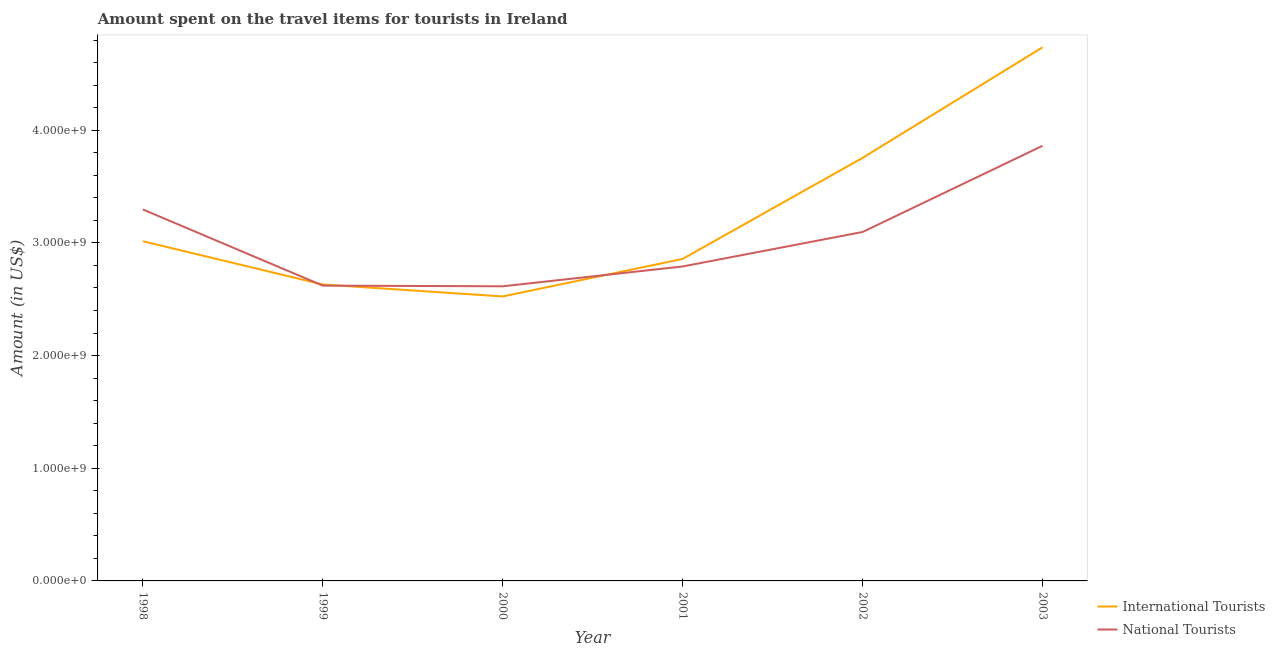How many different coloured lines are there?
Make the answer very short. 2. Is the number of lines equal to the number of legend labels?
Provide a succinct answer. Yes. What is the amount spent on travel items of international tourists in 2000?
Ensure brevity in your answer.  2.52e+09. Across all years, what is the maximum amount spent on travel items of national tourists?
Give a very brief answer. 3.86e+09. Across all years, what is the minimum amount spent on travel items of national tourists?
Provide a short and direct response. 2.62e+09. In which year was the amount spent on travel items of national tourists maximum?
Offer a very short reply. 2003. In which year was the amount spent on travel items of international tourists minimum?
Offer a very short reply. 2000. What is the total amount spent on travel items of international tourists in the graph?
Ensure brevity in your answer.  1.95e+1. What is the difference between the amount spent on travel items of international tourists in 2001 and that in 2002?
Provide a short and direct response. -8.97e+08. What is the difference between the amount spent on travel items of international tourists in 2002 and the amount spent on travel items of national tourists in 2000?
Ensure brevity in your answer.  1.14e+09. What is the average amount spent on travel items of international tourists per year?
Your response must be concise. 3.25e+09. In the year 2002, what is the difference between the amount spent on travel items of international tourists and amount spent on travel items of national tourists?
Offer a very short reply. 6.58e+08. What is the ratio of the amount spent on travel items of national tourists in 1999 to that in 2001?
Provide a succinct answer. 0.94. Is the difference between the amount spent on travel items of national tourists in 1999 and 2002 greater than the difference between the amount spent on travel items of international tourists in 1999 and 2002?
Provide a short and direct response. Yes. What is the difference between the highest and the second highest amount spent on travel items of national tourists?
Your response must be concise. 5.65e+08. What is the difference between the highest and the lowest amount spent on travel items of national tourists?
Provide a succinct answer. 1.25e+09. How many lines are there?
Offer a very short reply. 2. Does the graph contain any zero values?
Give a very brief answer. No. How many legend labels are there?
Offer a terse response. 2. How are the legend labels stacked?
Provide a succinct answer. Vertical. What is the title of the graph?
Offer a terse response. Amount spent on the travel items for tourists in Ireland. What is the label or title of the X-axis?
Provide a succinct answer. Year. What is the label or title of the Y-axis?
Your answer should be very brief. Amount (in US$). What is the Amount (in US$) in International Tourists in 1998?
Keep it short and to the point. 3.02e+09. What is the Amount (in US$) of National Tourists in 1998?
Offer a very short reply. 3.30e+09. What is the Amount (in US$) in International Tourists in 1999?
Your response must be concise. 2.63e+09. What is the Amount (in US$) in National Tourists in 1999?
Your answer should be very brief. 2.62e+09. What is the Amount (in US$) of International Tourists in 2000?
Give a very brief answer. 2.52e+09. What is the Amount (in US$) of National Tourists in 2000?
Offer a terse response. 2.62e+09. What is the Amount (in US$) of International Tourists in 2001?
Your response must be concise. 2.86e+09. What is the Amount (in US$) of National Tourists in 2001?
Your answer should be compact. 2.79e+09. What is the Amount (in US$) of International Tourists in 2002?
Provide a short and direct response. 3.76e+09. What is the Amount (in US$) of National Tourists in 2002?
Keep it short and to the point. 3.10e+09. What is the Amount (in US$) of International Tourists in 2003?
Provide a short and direct response. 4.74e+09. What is the Amount (in US$) of National Tourists in 2003?
Your answer should be compact. 3.86e+09. Across all years, what is the maximum Amount (in US$) of International Tourists?
Keep it short and to the point. 4.74e+09. Across all years, what is the maximum Amount (in US$) in National Tourists?
Your response must be concise. 3.86e+09. Across all years, what is the minimum Amount (in US$) in International Tourists?
Give a very brief answer. 2.52e+09. Across all years, what is the minimum Amount (in US$) of National Tourists?
Offer a terse response. 2.62e+09. What is the total Amount (in US$) of International Tourists in the graph?
Provide a succinct answer. 1.95e+1. What is the total Amount (in US$) in National Tourists in the graph?
Keep it short and to the point. 1.83e+1. What is the difference between the Amount (in US$) of International Tourists in 1998 and that in 1999?
Your response must be concise. 3.84e+08. What is the difference between the Amount (in US$) of National Tourists in 1998 and that in 1999?
Make the answer very short. 6.76e+08. What is the difference between the Amount (in US$) in International Tourists in 1998 and that in 2000?
Your answer should be very brief. 4.90e+08. What is the difference between the Amount (in US$) of National Tourists in 1998 and that in 2000?
Make the answer very short. 6.82e+08. What is the difference between the Amount (in US$) in International Tourists in 1998 and that in 2001?
Provide a short and direct response. 1.57e+08. What is the difference between the Amount (in US$) in National Tourists in 1998 and that in 2001?
Offer a terse response. 5.06e+08. What is the difference between the Amount (in US$) of International Tourists in 1998 and that in 2002?
Provide a short and direct response. -7.40e+08. What is the difference between the Amount (in US$) in National Tourists in 1998 and that in 2002?
Your answer should be very brief. 2.00e+08. What is the difference between the Amount (in US$) of International Tourists in 1998 and that in 2003?
Your answer should be compact. -1.72e+09. What is the difference between the Amount (in US$) of National Tourists in 1998 and that in 2003?
Provide a short and direct response. -5.65e+08. What is the difference between the Amount (in US$) in International Tourists in 1999 and that in 2000?
Offer a terse response. 1.06e+08. What is the difference between the Amount (in US$) of National Tourists in 1999 and that in 2000?
Give a very brief answer. 6.00e+06. What is the difference between the Amount (in US$) in International Tourists in 1999 and that in 2001?
Provide a short and direct response. -2.27e+08. What is the difference between the Amount (in US$) of National Tourists in 1999 and that in 2001?
Give a very brief answer. -1.70e+08. What is the difference between the Amount (in US$) in International Tourists in 1999 and that in 2002?
Your answer should be compact. -1.12e+09. What is the difference between the Amount (in US$) of National Tourists in 1999 and that in 2002?
Ensure brevity in your answer.  -4.76e+08. What is the difference between the Amount (in US$) in International Tourists in 1999 and that in 2003?
Ensure brevity in your answer.  -2.10e+09. What is the difference between the Amount (in US$) in National Tourists in 1999 and that in 2003?
Ensure brevity in your answer.  -1.24e+09. What is the difference between the Amount (in US$) of International Tourists in 2000 and that in 2001?
Give a very brief answer. -3.33e+08. What is the difference between the Amount (in US$) of National Tourists in 2000 and that in 2001?
Your answer should be compact. -1.76e+08. What is the difference between the Amount (in US$) in International Tourists in 2000 and that in 2002?
Give a very brief answer. -1.23e+09. What is the difference between the Amount (in US$) in National Tourists in 2000 and that in 2002?
Your answer should be compact. -4.82e+08. What is the difference between the Amount (in US$) of International Tourists in 2000 and that in 2003?
Provide a succinct answer. -2.21e+09. What is the difference between the Amount (in US$) in National Tourists in 2000 and that in 2003?
Give a very brief answer. -1.25e+09. What is the difference between the Amount (in US$) of International Tourists in 2001 and that in 2002?
Give a very brief answer. -8.97e+08. What is the difference between the Amount (in US$) in National Tourists in 2001 and that in 2002?
Keep it short and to the point. -3.06e+08. What is the difference between the Amount (in US$) in International Tourists in 2001 and that in 2003?
Provide a short and direct response. -1.88e+09. What is the difference between the Amount (in US$) of National Tourists in 2001 and that in 2003?
Give a very brief answer. -1.07e+09. What is the difference between the Amount (in US$) of International Tourists in 2002 and that in 2003?
Make the answer very short. -9.81e+08. What is the difference between the Amount (in US$) in National Tourists in 2002 and that in 2003?
Your answer should be compact. -7.65e+08. What is the difference between the Amount (in US$) in International Tourists in 1998 and the Amount (in US$) in National Tourists in 1999?
Offer a very short reply. 3.94e+08. What is the difference between the Amount (in US$) of International Tourists in 1998 and the Amount (in US$) of National Tourists in 2000?
Make the answer very short. 4.00e+08. What is the difference between the Amount (in US$) in International Tourists in 1998 and the Amount (in US$) in National Tourists in 2001?
Your answer should be compact. 2.24e+08. What is the difference between the Amount (in US$) of International Tourists in 1998 and the Amount (in US$) of National Tourists in 2002?
Your response must be concise. -8.20e+07. What is the difference between the Amount (in US$) of International Tourists in 1998 and the Amount (in US$) of National Tourists in 2003?
Offer a very short reply. -8.47e+08. What is the difference between the Amount (in US$) of International Tourists in 1999 and the Amount (in US$) of National Tourists in 2000?
Keep it short and to the point. 1.60e+07. What is the difference between the Amount (in US$) of International Tourists in 1999 and the Amount (in US$) of National Tourists in 2001?
Your response must be concise. -1.60e+08. What is the difference between the Amount (in US$) in International Tourists in 1999 and the Amount (in US$) in National Tourists in 2002?
Give a very brief answer. -4.66e+08. What is the difference between the Amount (in US$) in International Tourists in 1999 and the Amount (in US$) in National Tourists in 2003?
Ensure brevity in your answer.  -1.23e+09. What is the difference between the Amount (in US$) of International Tourists in 2000 and the Amount (in US$) of National Tourists in 2001?
Your response must be concise. -2.66e+08. What is the difference between the Amount (in US$) of International Tourists in 2000 and the Amount (in US$) of National Tourists in 2002?
Keep it short and to the point. -5.72e+08. What is the difference between the Amount (in US$) in International Tourists in 2000 and the Amount (in US$) in National Tourists in 2003?
Provide a succinct answer. -1.34e+09. What is the difference between the Amount (in US$) in International Tourists in 2001 and the Amount (in US$) in National Tourists in 2002?
Provide a short and direct response. -2.39e+08. What is the difference between the Amount (in US$) of International Tourists in 2001 and the Amount (in US$) of National Tourists in 2003?
Keep it short and to the point. -1.00e+09. What is the difference between the Amount (in US$) of International Tourists in 2002 and the Amount (in US$) of National Tourists in 2003?
Provide a succinct answer. -1.07e+08. What is the average Amount (in US$) in International Tourists per year?
Give a very brief answer. 3.25e+09. What is the average Amount (in US$) in National Tourists per year?
Ensure brevity in your answer.  3.05e+09. In the year 1998, what is the difference between the Amount (in US$) of International Tourists and Amount (in US$) of National Tourists?
Your response must be concise. -2.82e+08. In the year 1999, what is the difference between the Amount (in US$) in International Tourists and Amount (in US$) in National Tourists?
Your answer should be very brief. 1.00e+07. In the year 2000, what is the difference between the Amount (in US$) of International Tourists and Amount (in US$) of National Tourists?
Provide a short and direct response. -9.00e+07. In the year 2001, what is the difference between the Amount (in US$) in International Tourists and Amount (in US$) in National Tourists?
Your answer should be very brief. 6.70e+07. In the year 2002, what is the difference between the Amount (in US$) in International Tourists and Amount (in US$) in National Tourists?
Give a very brief answer. 6.58e+08. In the year 2003, what is the difference between the Amount (in US$) in International Tourists and Amount (in US$) in National Tourists?
Offer a terse response. 8.74e+08. What is the ratio of the Amount (in US$) in International Tourists in 1998 to that in 1999?
Ensure brevity in your answer.  1.15. What is the ratio of the Amount (in US$) of National Tourists in 1998 to that in 1999?
Offer a very short reply. 1.26. What is the ratio of the Amount (in US$) in International Tourists in 1998 to that in 2000?
Make the answer very short. 1.19. What is the ratio of the Amount (in US$) in National Tourists in 1998 to that in 2000?
Provide a succinct answer. 1.26. What is the ratio of the Amount (in US$) in International Tourists in 1998 to that in 2001?
Provide a succinct answer. 1.05. What is the ratio of the Amount (in US$) of National Tourists in 1998 to that in 2001?
Offer a terse response. 1.18. What is the ratio of the Amount (in US$) of International Tourists in 1998 to that in 2002?
Give a very brief answer. 0.8. What is the ratio of the Amount (in US$) in National Tourists in 1998 to that in 2002?
Offer a very short reply. 1.06. What is the ratio of the Amount (in US$) of International Tourists in 1998 to that in 2003?
Your answer should be very brief. 0.64. What is the ratio of the Amount (in US$) in National Tourists in 1998 to that in 2003?
Your response must be concise. 0.85. What is the ratio of the Amount (in US$) in International Tourists in 1999 to that in 2000?
Provide a short and direct response. 1.04. What is the ratio of the Amount (in US$) of International Tourists in 1999 to that in 2001?
Provide a short and direct response. 0.92. What is the ratio of the Amount (in US$) in National Tourists in 1999 to that in 2001?
Ensure brevity in your answer.  0.94. What is the ratio of the Amount (in US$) in International Tourists in 1999 to that in 2002?
Provide a short and direct response. 0.7. What is the ratio of the Amount (in US$) in National Tourists in 1999 to that in 2002?
Offer a terse response. 0.85. What is the ratio of the Amount (in US$) in International Tourists in 1999 to that in 2003?
Offer a very short reply. 0.56. What is the ratio of the Amount (in US$) of National Tourists in 1999 to that in 2003?
Provide a short and direct response. 0.68. What is the ratio of the Amount (in US$) in International Tourists in 2000 to that in 2001?
Your answer should be compact. 0.88. What is the ratio of the Amount (in US$) in National Tourists in 2000 to that in 2001?
Give a very brief answer. 0.94. What is the ratio of the Amount (in US$) of International Tourists in 2000 to that in 2002?
Offer a very short reply. 0.67. What is the ratio of the Amount (in US$) of National Tourists in 2000 to that in 2002?
Give a very brief answer. 0.84. What is the ratio of the Amount (in US$) in International Tourists in 2000 to that in 2003?
Offer a terse response. 0.53. What is the ratio of the Amount (in US$) of National Tourists in 2000 to that in 2003?
Ensure brevity in your answer.  0.68. What is the ratio of the Amount (in US$) of International Tourists in 2001 to that in 2002?
Provide a short and direct response. 0.76. What is the ratio of the Amount (in US$) of National Tourists in 2001 to that in 2002?
Provide a succinct answer. 0.9. What is the ratio of the Amount (in US$) in International Tourists in 2001 to that in 2003?
Make the answer very short. 0.6. What is the ratio of the Amount (in US$) of National Tourists in 2001 to that in 2003?
Keep it short and to the point. 0.72. What is the ratio of the Amount (in US$) in International Tourists in 2002 to that in 2003?
Your answer should be very brief. 0.79. What is the ratio of the Amount (in US$) of National Tourists in 2002 to that in 2003?
Provide a short and direct response. 0.8. What is the difference between the highest and the second highest Amount (in US$) of International Tourists?
Make the answer very short. 9.81e+08. What is the difference between the highest and the second highest Amount (in US$) of National Tourists?
Provide a short and direct response. 5.65e+08. What is the difference between the highest and the lowest Amount (in US$) of International Tourists?
Offer a terse response. 2.21e+09. What is the difference between the highest and the lowest Amount (in US$) of National Tourists?
Ensure brevity in your answer.  1.25e+09. 